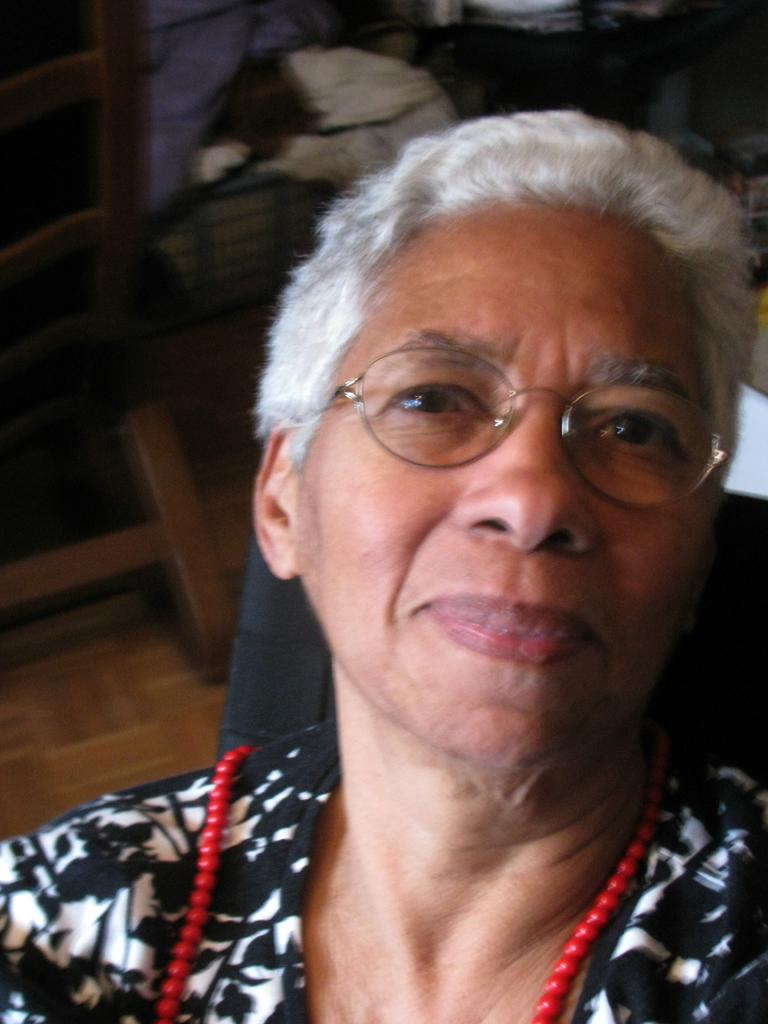Who is present in the image? There is a woman in the image. What is the woman doing in the image? The woman is sitting in a chair. Can you describe the chair the woman is sitting on? There is a chair in the image, and the woman is sitting on it. What else can be seen in the background of the image? There are other objects in the background of the image, but their nature is unclear. What type of dog is sitting next to the woman in the image? There is no dog present in the image; only the woman and a chair are visible. 